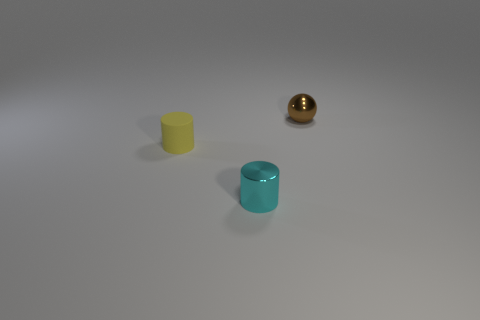What number of tiny things are to the right of the brown shiny sphere? 0 